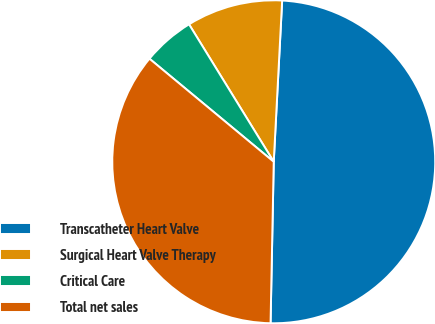<chart> <loc_0><loc_0><loc_500><loc_500><pie_chart><fcel>Transcatheter Heart Valve<fcel>Surgical Heart Valve Therapy<fcel>Critical Care<fcel>Total net sales<nl><fcel>49.49%<fcel>9.62%<fcel>5.19%<fcel>35.71%<nl></chart> 